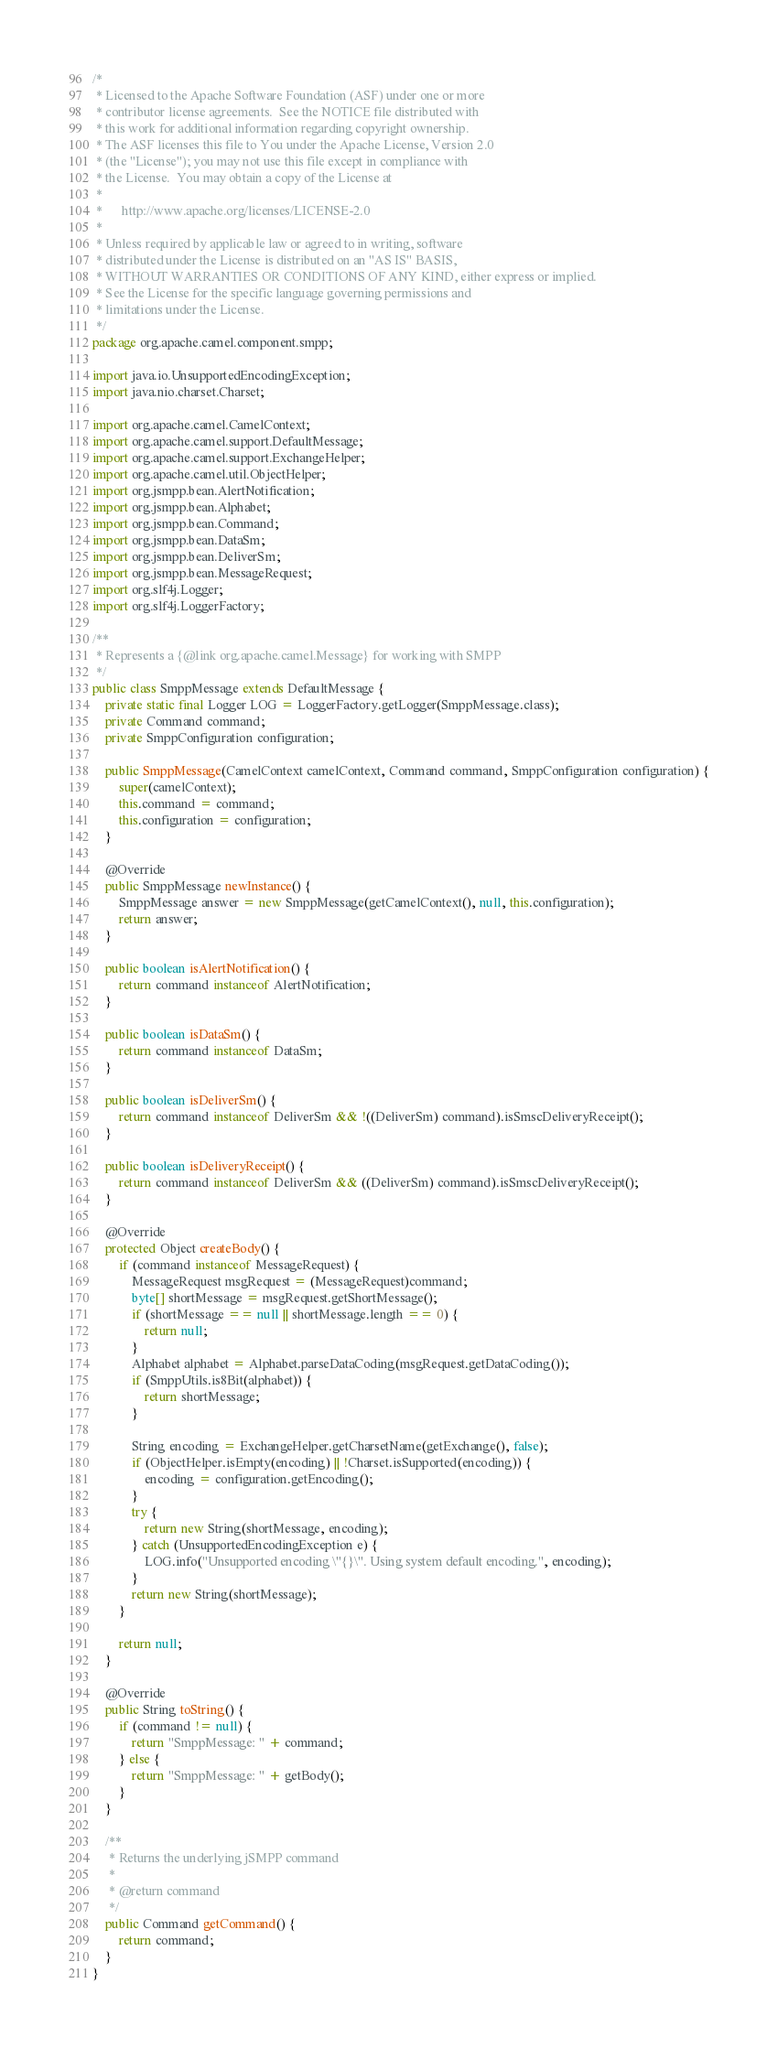Convert code to text. <code><loc_0><loc_0><loc_500><loc_500><_Java_>/*
 * Licensed to the Apache Software Foundation (ASF) under one or more
 * contributor license agreements.  See the NOTICE file distributed with
 * this work for additional information regarding copyright ownership.
 * The ASF licenses this file to You under the Apache License, Version 2.0
 * (the "License"); you may not use this file except in compliance with
 * the License.  You may obtain a copy of the License at
 *
 *      http://www.apache.org/licenses/LICENSE-2.0
 *
 * Unless required by applicable law or agreed to in writing, software
 * distributed under the License is distributed on an "AS IS" BASIS,
 * WITHOUT WARRANTIES OR CONDITIONS OF ANY KIND, either express or implied.
 * See the License for the specific language governing permissions and
 * limitations under the License.
 */
package org.apache.camel.component.smpp;

import java.io.UnsupportedEncodingException;
import java.nio.charset.Charset;

import org.apache.camel.CamelContext;
import org.apache.camel.support.DefaultMessage;
import org.apache.camel.support.ExchangeHelper;
import org.apache.camel.util.ObjectHelper;
import org.jsmpp.bean.AlertNotification;
import org.jsmpp.bean.Alphabet;
import org.jsmpp.bean.Command;
import org.jsmpp.bean.DataSm;
import org.jsmpp.bean.DeliverSm;
import org.jsmpp.bean.MessageRequest;
import org.slf4j.Logger;
import org.slf4j.LoggerFactory;

/**
 * Represents a {@link org.apache.camel.Message} for working with SMPP
 */
public class SmppMessage extends DefaultMessage {
    private static final Logger LOG = LoggerFactory.getLogger(SmppMessage.class);
    private Command command;
    private SmppConfiguration configuration;

    public SmppMessage(CamelContext camelContext, Command command, SmppConfiguration configuration) {
        super(camelContext);
        this.command = command;
        this.configuration = configuration;
    }

    @Override
    public SmppMessage newInstance() {
        SmppMessage answer = new SmppMessage(getCamelContext(), null, this.configuration);
        return answer;
    }
    
    public boolean isAlertNotification() {
        return command instanceof AlertNotification;
    }
    
    public boolean isDataSm() {
        return command instanceof DataSm;
    }
    
    public boolean isDeliverSm() {
        return command instanceof DeliverSm && !((DeliverSm) command).isSmscDeliveryReceipt();
    }
    
    public boolean isDeliveryReceipt() {
        return command instanceof DeliverSm && ((DeliverSm) command).isSmscDeliveryReceipt();
    }

    @Override
    protected Object createBody() {
        if (command instanceof MessageRequest) {
            MessageRequest msgRequest = (MessageRequest)command;
            byte[] shortMessage = msgRequest.getShortMessage();
            if (shortMessage == null || shortMessage.length == 0) {
                return null;
            }
            Alphabet alphabet = Alphabet.parseDataCoding(msgRequest.getDataCoding());
            if (SmppUtils.is8Bit(alphabet)) {
                return shortMessage;
            }
            
            String encoding = ExchangeHelper.getCharsetName(getExchange(), false);
            if (ObjectHelper.isEmpty(encoding) || !Charset.isSupported(encoding)) {
                encoding = configuration.getEncoding();
            }
            try {
                return new String(shortMessage, encoding);
            } catch (UnsupportedEncodingException e) {
                LOG.info("Unsupported encoding \"{}\". Using system default encoding.", encoding);
            }
            return new String(shortMessage);
        }

        return null;
    }

    @Override
    public String toString() {
        if (command != null) {
            return "SmppMessage: " + command;
        } else {
            return "SmppMessage: " + getBody();
        }
    }

    /**
     * Returns the underlying jSMPP command
     * 
     * @return command
     */
    public Command getCommand() {
        return command;
    }
}</code> 